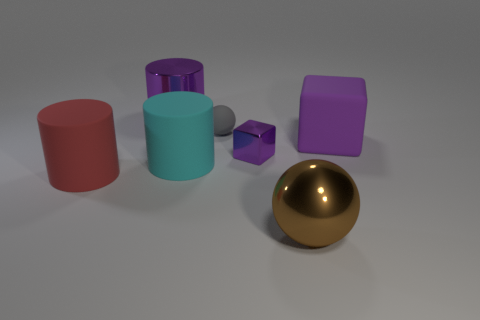Subtract all brown cylinders. Subtract all cyan balls. How many cylinders are left? 3 Add 2 large brown cubes. How many objects exist? 9 Subtract all cylinders. How many objects are left? 4 Subtract all gray rubber cylinders. Subtract all shiny cubes. How many objects are left? 6 Add 2 gray matte things. How many gray matte things are left? 3 Add 5 small purple shiny things. How many small purple shiny things exist? 6 Subtract 0 red spheres. How many objects are left? 7 